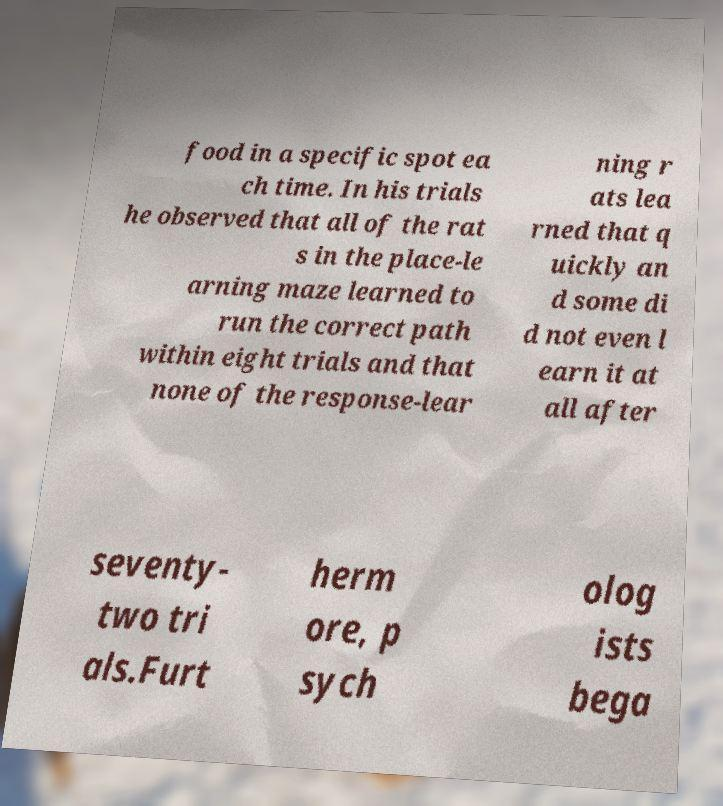I need the written content from this picture converted into text. Can you do that? food in a specific spot ea ch time. In his trials he observed that all of the rat s in the place-le arning maze learned to run the correct path within eight trials and that none of the response-lear ning r ats lea rned that q uickly an d some di d not even l earn it at all after seventy- two tri als.Furt herm ore, p sych olog ists bega 